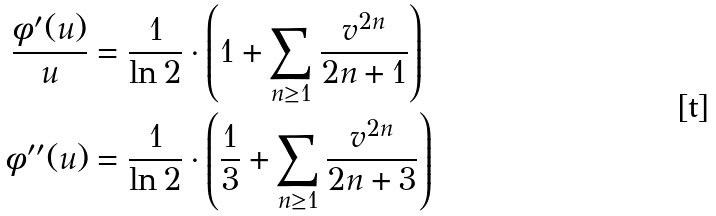Convert formula to latex. <formula><loc_0><loc_0><loc_500><loc_500>\frac { \phi ^ { \prime } ( u ) } { u } & = \frac { 1 } { \ln 2 } \cdot \left ( 1 + \sum _ { n \geq 1 } \frac { v ^ { 2 n } } { 2 n + 1 } \right ) \\ \phi ^ { \prime \prime } ( u ) & = \frac { 1 } { \ln 2 } \cdot \left ( \frac { 1 } { 3 } + \sum _ { n \geq 1 } \frac { v ^ { 2 n } } { 2 n + 3 } \right )</formula> 